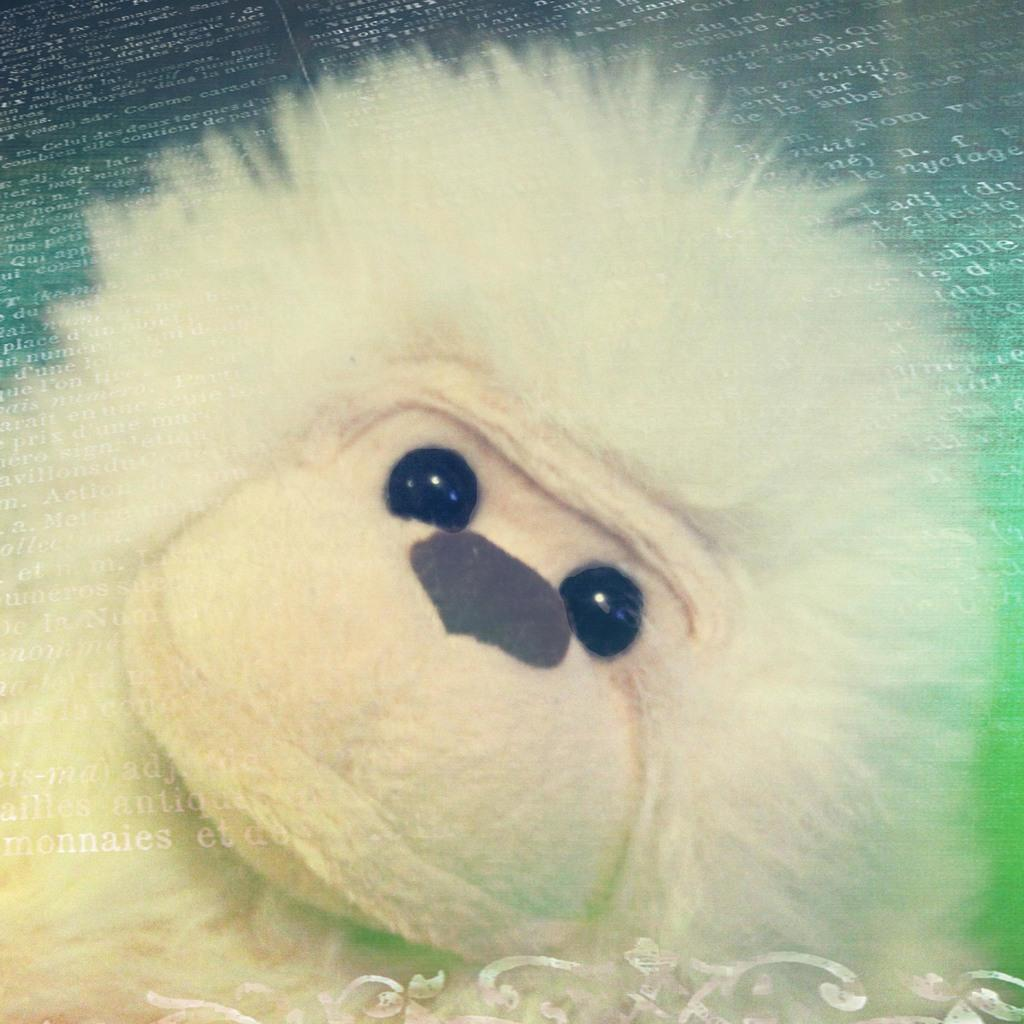What object can be seen in the image that resembles a toy? There is a toy in the image. Can you describe any imperfections or marks on the image? There are watermarks on the image. How many kittens can be seen playing with the toy in the image? There are no kittens present in the image; it only features a toy. What type of attraction is visible in the background of the image? There is no background or attraction visible in the image; it only features a toy and watermarks. 